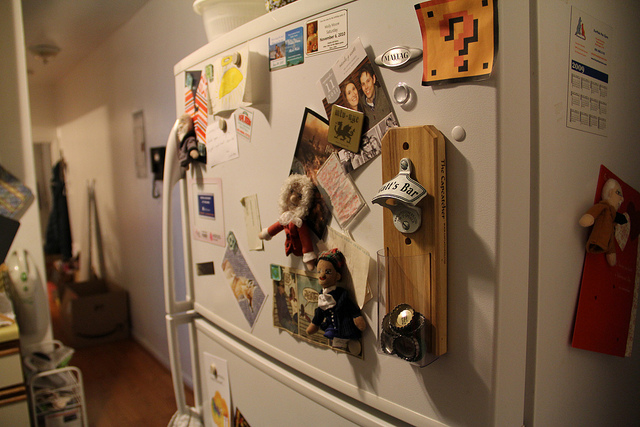Please transcribe the text in this image. Bar 